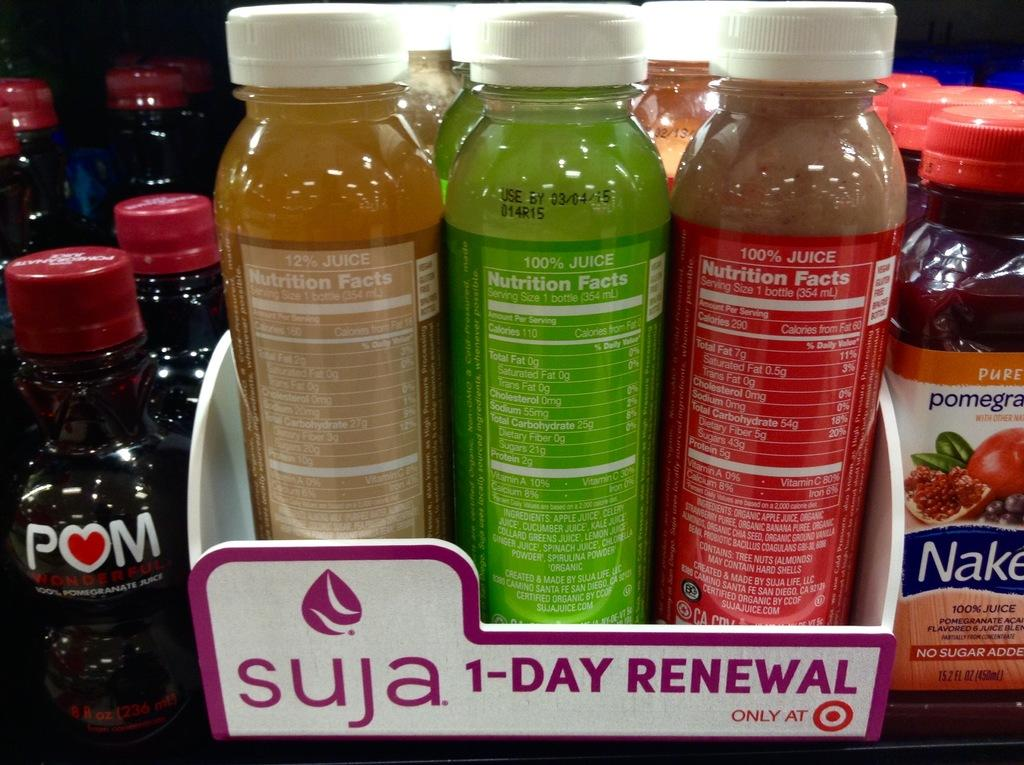<image>
Give a short and clear explanation of the subsequent image. Multiple bottles of juices are shown, including Suja. 